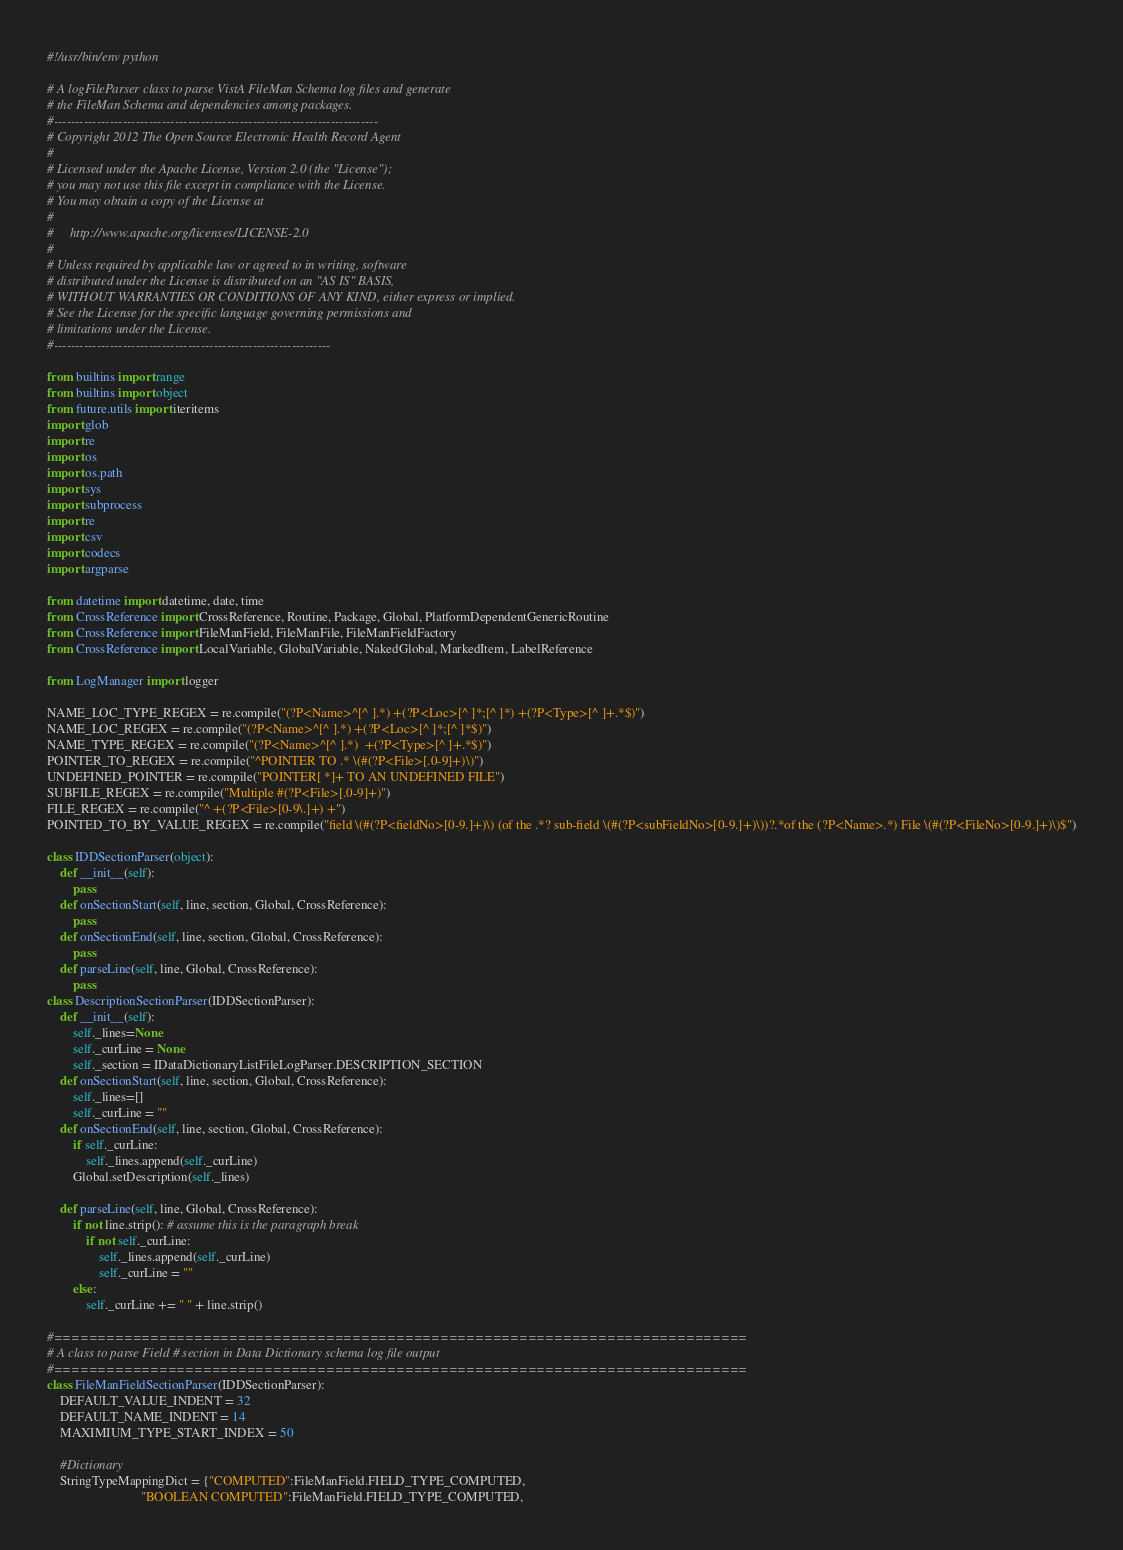<code> <loc_0><loc_0><loc_500><loc_500><_Python_>#!/usr/bin/env python

# A logFileParser class to parse VistA FileMan Schema log files and generate
# the FileMan Schema and dependencies among packages.
#---------------------------------------------------------------------------
# Copyright 2012 The Open Source Electronic Health Record Agent
#
# Licensed under the Apache License, Version 2.0 (the "License");
# you may not use this file except in compliance with the License.
# You may obtain a copy of the License at
#
#     http://www.apache.org/licenses/LICENSE-2.0
#
# Unless required by applicable law or agreed to in writing, software
# distributed under the License is distributed on an "AS IS" BASIS,
# WITHOUT WARRANTIES OR CONDITIONS OF ANY KIND, either express or implied.
# See the License for the specific language governing permissions and
# limitations under the License.
#----------------------------------------------------------------

from builtins import range
from builtins import object
from future.utils import iteritems
import glob
import re
import os
import os.path
import sys
import subprocess
import re
import csv
import codecs
import argparse

from datetime import datetime, date, time
from CrossReference import CrossReference, Routine, Package, Global, PlatformDependentGenericRoutine
from CrossReference import FileManField, FileManFile, FileManFieldFactory
from CrossReference import LocalVariable, GlobalVariable, NakedGlobal, MarkedItem, LabelReference

from LogManager import logger

NAME_LOC_TYPE_REGEX = re.compile("(?P<Name>^[^ ].*) +(?P<Loc>[^ ]*;[^ ]*) +(?P<Type>[^ ]+.*$)")
NAME_LOC_REGEX = re.compile("(?P<Name>^[^ ].*) +(?P<Loc>[^ ]*;[^ ]*$)")
NAME_TYPE_REGEX = re.compile("(?P<Name>^[^ ].*)  +(?P<Type>[^ ]+.*$)")
POINTER_TO_REGEX = re.compile("^POINTER TO .* \(#(?P<File>[.0-9]+)\)")
UNDEFINED_POINTER = re.compile("POINTER[ *]+ TO AN UNDEFINED FILE")
SUBFILE_REGEX = re.compile("Multiple #(?P<File>[.0-9]+)")
FILE_REGEX = re.compile("^ +(?P<File>[0-9\.]+) +")
POINTED_TO_BY_VALUE_REGEX = re.compile("field \(#(?P<fieldNo>[0-9.]+)\) (of the .*? sub-field \(#(?P<subFieldNo>[0-9.]+)\))?.*of the (?P<Name>.*) File \(#(?P<FileNo>[0-9.]+)\)$")

class IDDSectionParser(object):
    def __init__(self):
        pass
    def onSectionStart(self, line, section, Global, CrossReference):
        pass
    def onSectionEnd(self, line, section, Global, CrossReference):
        pass
    def parseLine(self, line, Global, CrossReference):
        pass
class DescriptionSectionParser(IDDSectionParser):
    def __init__(self):
        self._lines=None
        self._curLine = None
        self._section = IDataDictionaryListFileLogParser.DESCRIPTION_SECTION
    def onSectionStart(self, line, section, Global, CrossReference):
        self._lines=[]
        self._curLine = ""
    def onSectionEnd(self, line, section, Global, CrossReference):
        if self._curLine:
            self._lines.append(self._curLine)
        Global.setDescription(self._lines)

    def parseLine(self, line, Global, CrossReference):
        if not line.strip(): # assume this is the paragraph break
            if not self._curLine:
                self._lines.append(self._curLine)
                self._curLine = ""
        else:
            self._curLine += " " + line.strip()

#===============================================================================
# A class to parse Field # section in Data Dictionary schema log file output
#===============================================================================
class FileManFieldSectionParser(IDDSectionParser):
    DEFAULT_VALUE_INDENT = 32
    DEFAULT_NAME_INDENT = 14
    MAXIMIUM_TYPE_START_INDEX = 50

    #Dictionary
    StringTypeMappingDict = {"COMPUTED":FileManField.FIELD_TYPE_COMPUTED,
                             "BOOLEAN COMPUTED":FileManField.FIELD_TYPE_COMPUTED,</code> 